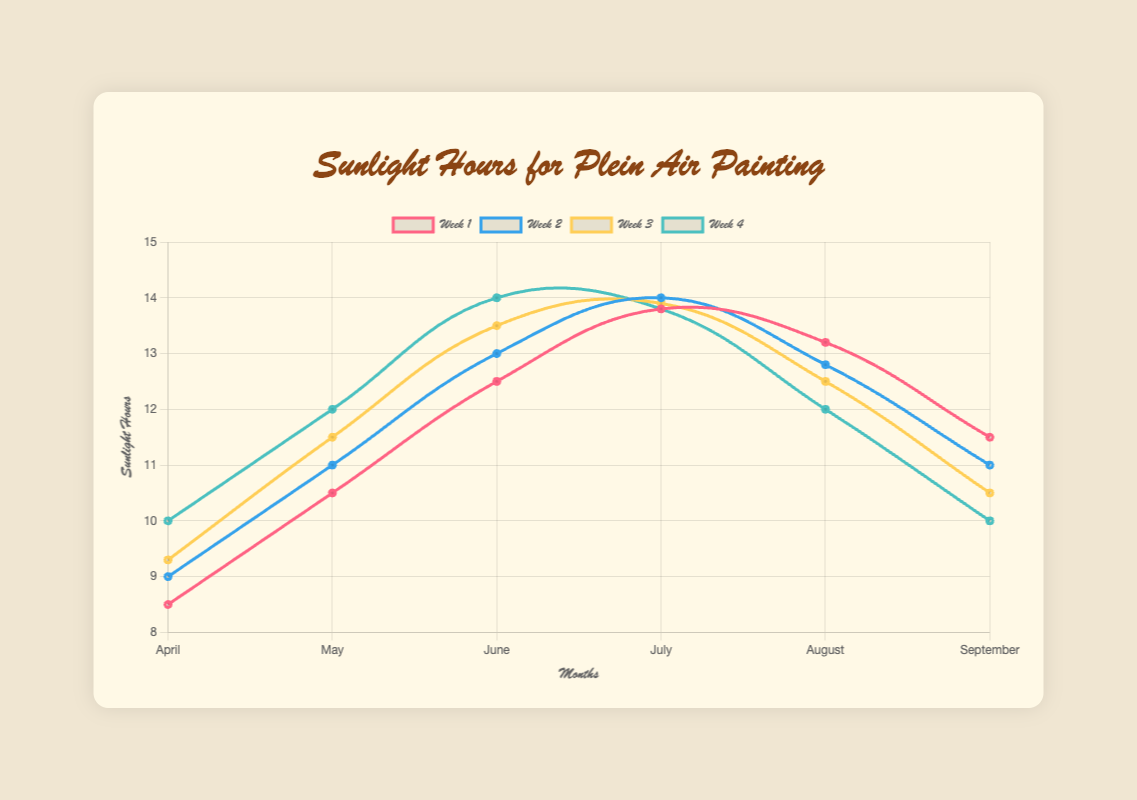How does the sunlight hours in Week 3 of April compare to Week 3 of August? Week 3 of April has 9.3 hours, and Week 3 of August has 12.5 hours. Comparing these, Week 3 of August has more sunlight hours.
Answer: August Week 3 has more sunlight Which month shows the highest average sunlight hours across all weeks? Calculate the average for each month. April: (8.5 + 9.0 + 9.3 + 10.0) / 4 = 9.2, May: (10.5 + 11.0 + 11.5 + 12.0) / 4 = 11.25, June: (12.5 + 13.0 + 13.5 + 14.0) / 4 = 13.25, July: (13.8 + 14.0 + 13.9 + 13.8) / 4 = 13.875, August: (13.2 + 12.8 + 12.5 + 12.0) / 4 = 12.625, September: (11.5 + 11.0 + 10.5 + 10.0) / 4 = 10.75. July has the highest average sunlight hours.
Answer: July What is the total increase in sunlight hours from Week 1 to Week 4 in June? Week 1 in June has 12.5 hours, and Week 4 has 14.0 hours. The increase is 14.0 - 12.5 = 1.5 hours.
Answer: 1.5 hours Compare the fluctuation in sunlight hours in July and August. Which month has less fluctuation? Fluctuation is the range (max minus min). July: max 14.0, min 13.8, fluctuation = 14.0 - 13.8 = 0.2. August: max 13.2, min 12.0, fluctuation = 13.2 - 12.0 = 1.2. July has less fluctuation.
Answer: July Which week generally sees the highest sunlight hours across the months? By checking the data, Week 4 of June has the highest value at 14.0 hours across all weeks and months.
Answer: Week 4, June In which month does Week 2 show the maximum increase from Week 1? Calculate the increase for each month: April: Week 2 - Week 1 = 9.0 - 8.5 = 0.5, May: Week 2 - Week 1 = 11.0 - 10.5 = 0.5, June: Week 2 - Week 1 = 13.0 - 12.5 = 0.5, July: Week 2 - Week 1 = 14.0 - 13.8 = 0.2, August: Week 2 - Week 1 = 12.8 - 13.2 = -0.4 (decrease), September: Week 2 - Week 1 = 11.0 - 11.5 = -0.5 (decrease). No month stands out as having a unique maximum increase, three months share the same increase.
Answer: April, May, June 